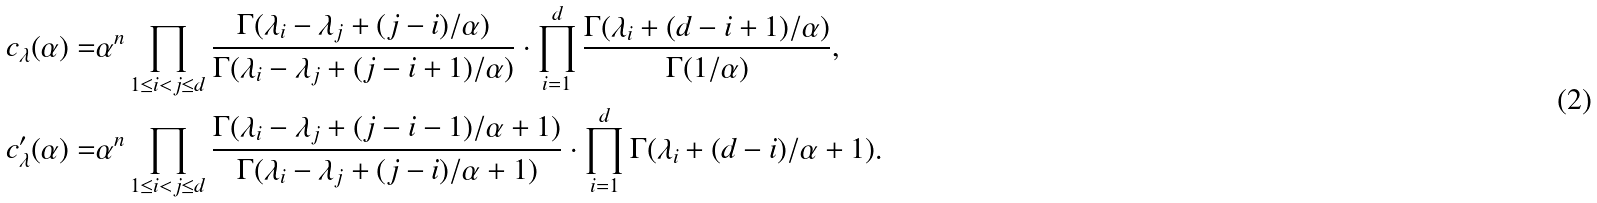Convert formula to latex. <formula><loc_0><loc_0><loc_500><loc_500>c _ { \lambda } ( \alpha ) = & \alpha ^ { n } \prod _ { 1 \leq i < j \leq d } \frac { \Gamma ( \lambda _ { i } - \lambda _ { j } + ( j - i ) / \alpha ) } { \Gamma ( \lambda _ { i } - \lambda _ { j } + ( j - i + 1 ) / \alpha ) } \cdot \prod _ { i = 1 } ^ { d } \frac { \Gamma ( \lambda _ { i } + ( d - i + 1 ) / \alpha ) } { \Gamma ( 1 / \alpha ) } , \\ c ^ { \prime } _ { \lambda } ( \alpha ) = & \alpha ^ { n } \prod _ { 1 \leq i < j \leq d } \frac { \Gamma ( \lambda _ { i } - \lambda _ { j } + ( j - i - 1 ) / \alpha + 1 ) } { \Gamma ( \lambda _ { i } - \lambda _ { j } + ( j - i ) / \alpha + 1 ) } \cdot \prod _ { i = 1 } ^ { d } \Gamma ( \lambda _ { i } + ( d - i ) / \alpha + 1 ) .</formula> 